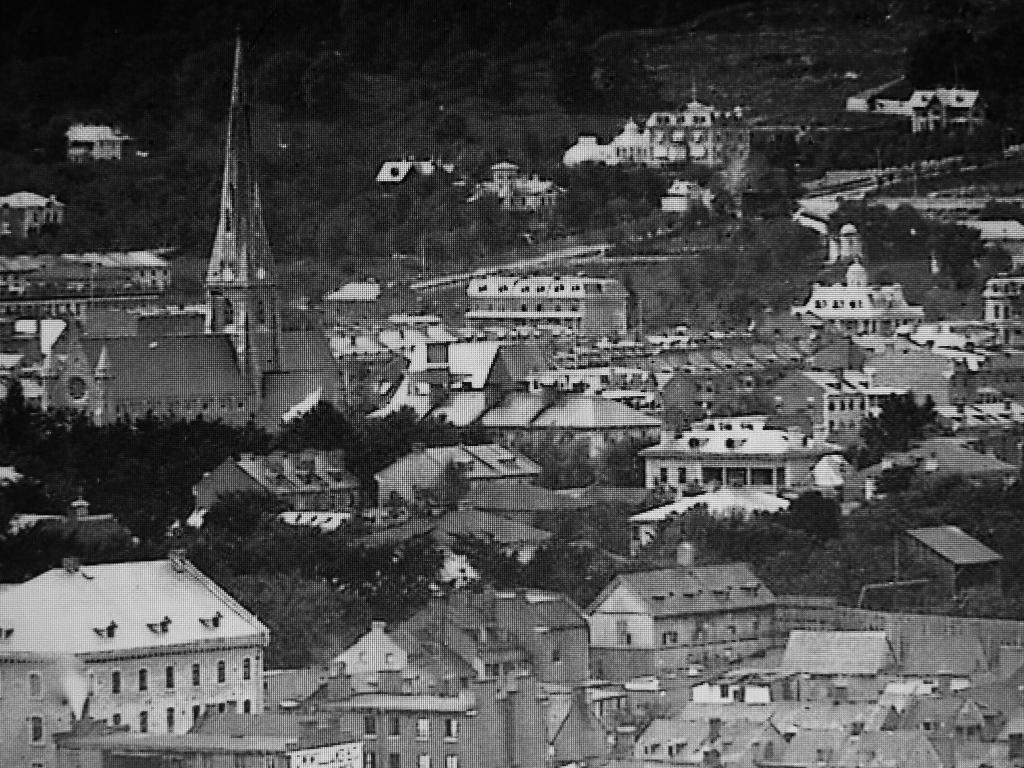What type of picture is shown in the image? The image is an old black and white picture. What structures can be seen in the image? There are houses in the image. What type of vegetation is present in the image? There are trees in the image. What geographical feature is visible behind the houses? There is a hill visible behind the houses. What color is the gold suit worn by the person on the hill in the image? There is no person wearing a gold suit on the hill in the image, as the hill is the only feature visible in that area. 